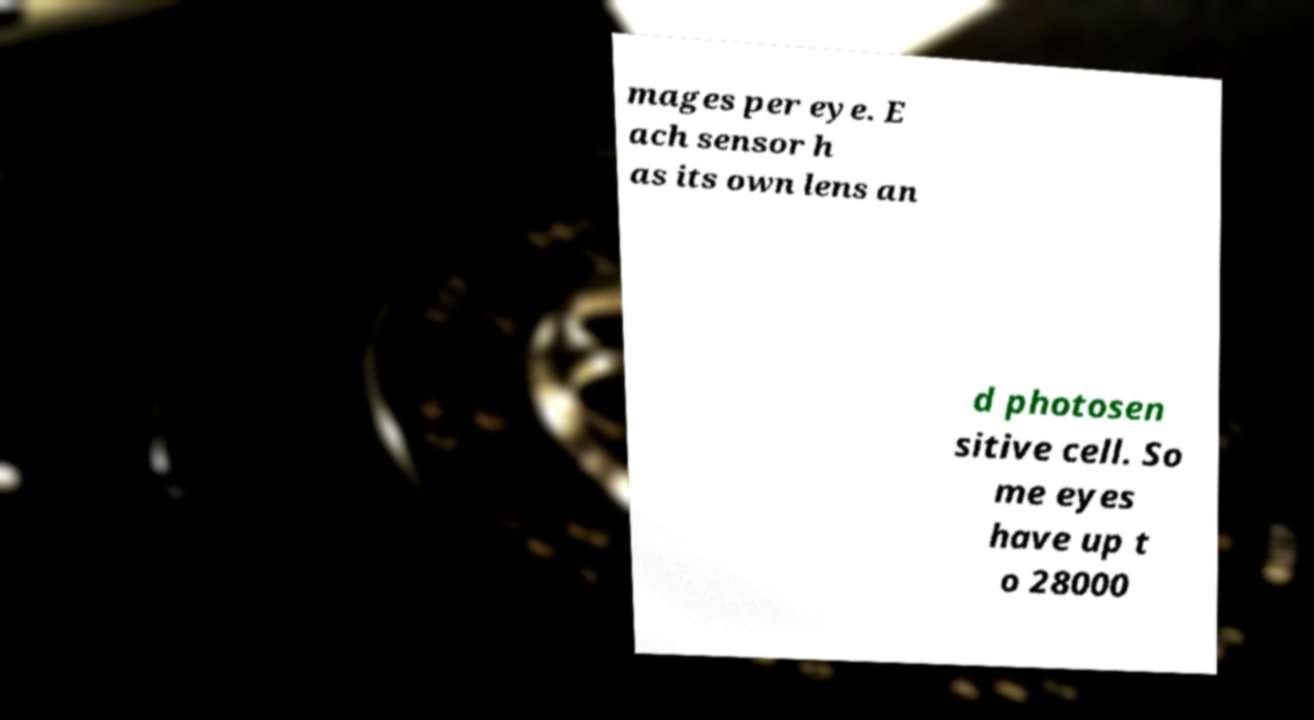Please identify and transcribe the text found in this image. mages per eye. E ach sensor h as its own lens an d photosen sitive cell. So me eyes have up t o 28000 